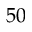<formula> <loc_0><loc_0><loc_500><loc_500>5 0</formula> 